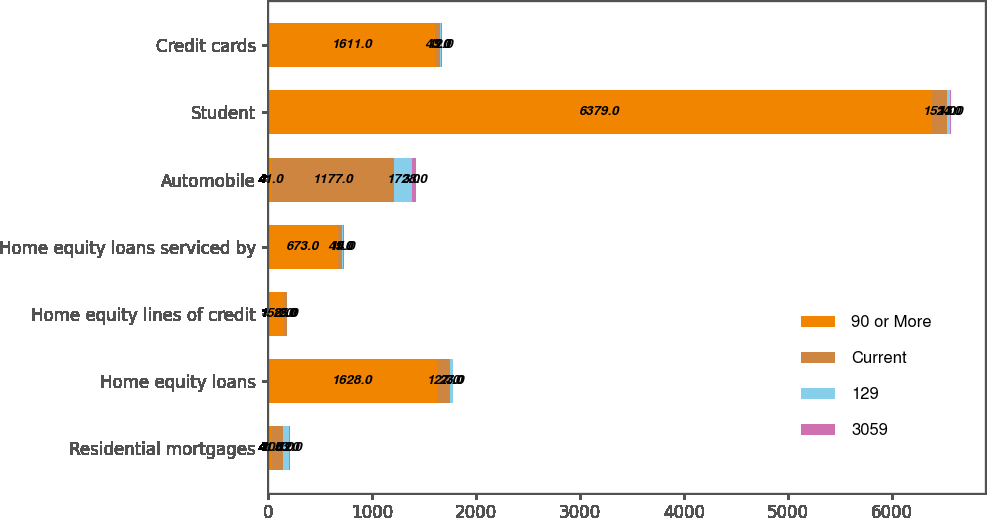<chart> <loc_0><loc_0><loc_500><loc_500><stacked_bar_chart><ecel><fcel>Residential mortgages<fcel>Home equity loans<fcel>Home equity lines of credit<fcel>Home equity loans serviced by<fcel>Automobile<fcel>Student<fcel>Credit cards<nl><fcel>90 or More<fcel>41<fcel>1628<fcel>158<fcel>673<fcel>41<fcel>6379<fcel>1611<nl><fcel>Current<fcel>108<fcel>127<fcel>25<fcel>41<fcel>1177<fcel>151<fcel>43<nl><fcel>129<fcel>53<fcel>23<fcel>3<fcel>14<fcel>172<fcel>24<fcel>12<nl><fcel>3059<fcel>12<fcel>7<fcel>2<fcel>5<fcel>38<fcel>13<fcel>9<nl></chart> 